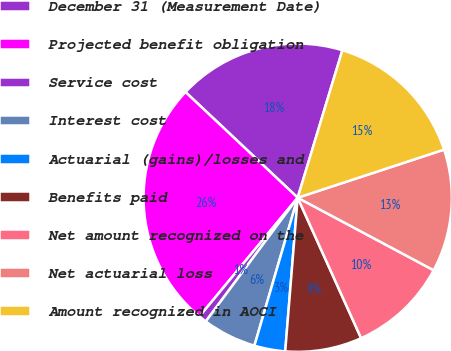<chart> <loc_0><loc_0><loc_500><loc_500><pie_chart><fcel>December 31 (Measurement Date)<fcel>Projected benefit obligation<fcel>Service cost<fcel>Interest cost<fcel>Actuarial (gains)/losses and<fcel>Benefits paid<fcel>Net amount recognized on the<fcel>Net actuarial loss<fcel>Amount recognized in AOCI<nl><fcel>17.66%<fcel>26.02%<fcel>0.83%<fcel>5.64%<fcel>3.24%<fcel>8.04%<fcel>10.45%<fcel>12.85%<fcel>15.26%<nl></chart> 